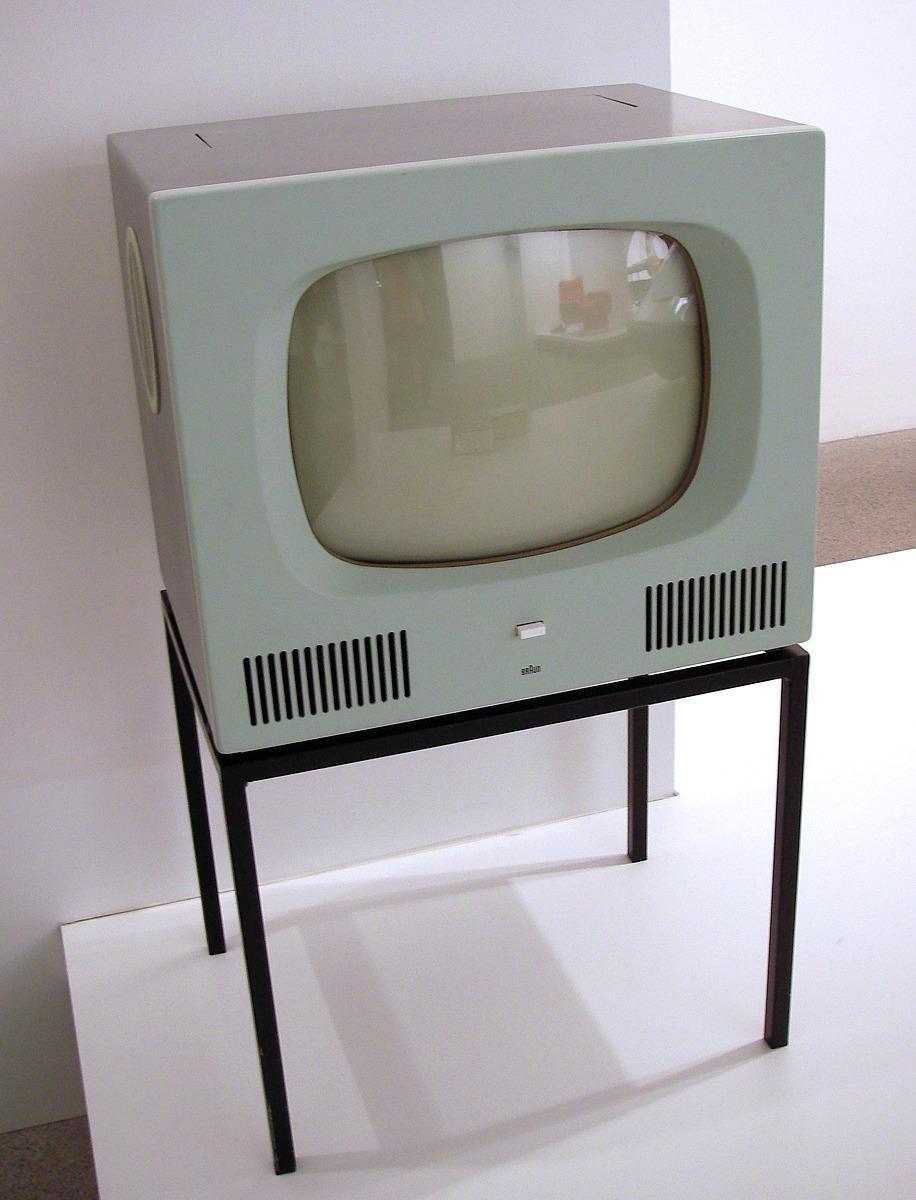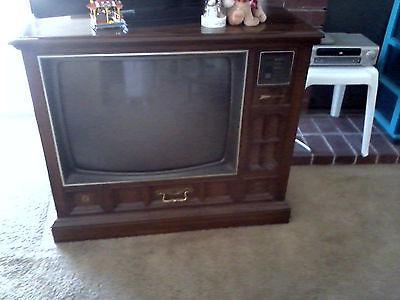The first image is the image on the left, the second image is the image on the right. Examine the images to the left and right. Is the description "There are exactly two knobs one the television in the image on the right." accurate? Answer yes or no. No. The first image is the image on the left, the second image is the image on the right. For the images shown, is this caption "One of the TV sets does not have legs under it." true? Answer yes or no. Yes. 